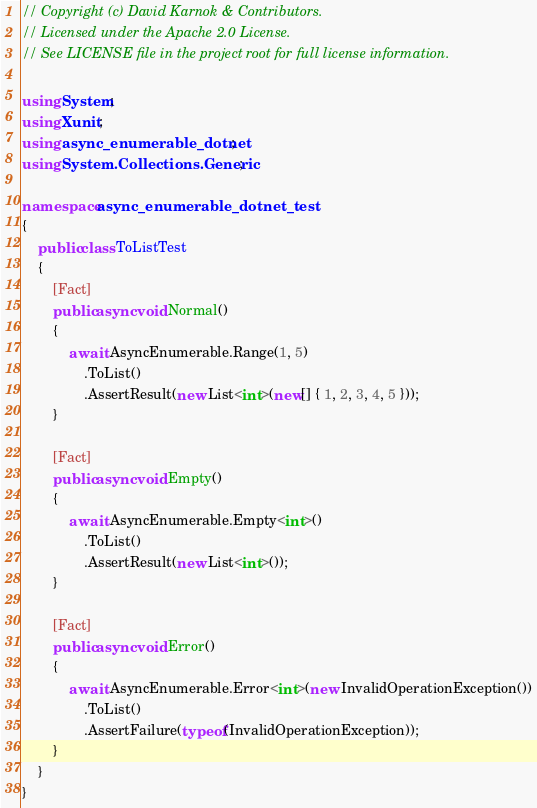Convert code to text. <code><loc_0><loc_0><loc_500><loc_500><_C#_>// Copyright (c) David Karnok & Contributors.
// Licensed under the Apache 2.0 License.
// See LICENSE file in the project root for full license information.

using System;
using Xunit;
using async_enumerable_dotnet;
using System.Collections.Generic;

namespace async_enumerable_dotnet_test
{
    public class ToListTest
    {
        [Fact]
        public async void Normal()
        {
            await AsyncEnumerable.Range(1, 5)
                .ToList()
                .AssertResult(new List<int>(new[] { 1, 2, 3, 4, 5 }));
        }

        [Fact]
        public async void Empty()
        {
            await AsyncEnumerable.Empty<int>()
                .ToList()
                .AssertResult(new List<int>());
        }

        [Fact]
        public async void Error()
        {
            await AsyncEnumerable.Error<int>(new InvalidOperationException())
                .ToList()
                .AssertFailure(typeof(InvalidOperationException));
        }
    }
}
</code> 